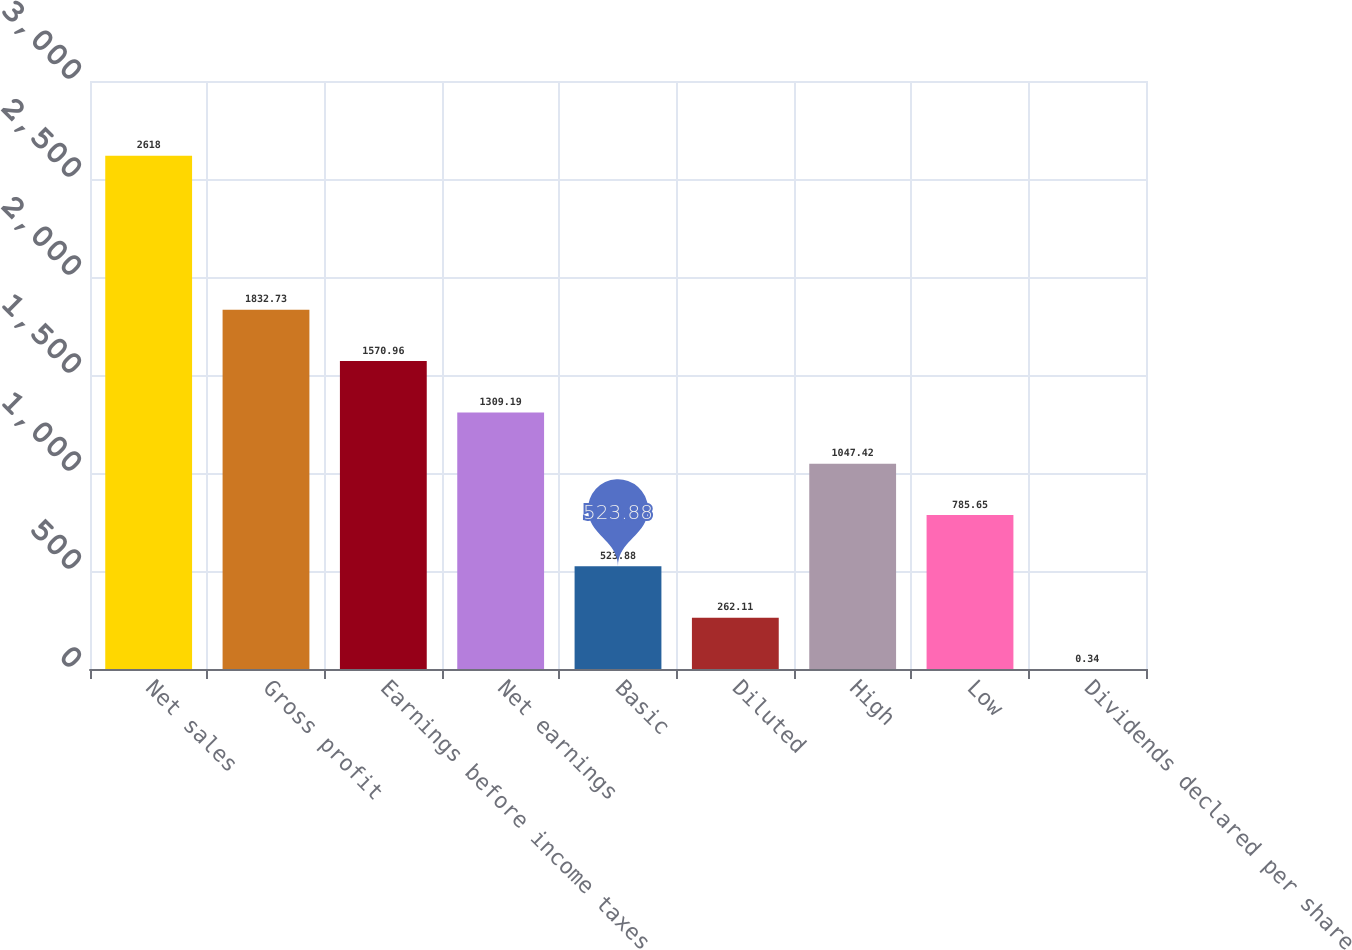<chart> <loc_0><loc_0><loc_500><loc_500><bar_chart><fcel>Net sales<fcel>Gross profit<fcel>Earnings before income taxes<fcel>Net earnings<fcel>Basic<fcel>Diluted<fcel>High<fcel>Low<fcel>Dividends declared per share<nl><fcel>2618<fcel>1832.73<fcel>1570.96<fcel>1309.19<fcel>523.88<fcel>262.11<fcel>1047.42<fcel>785.65<fcel>0.34<nl></chart> 